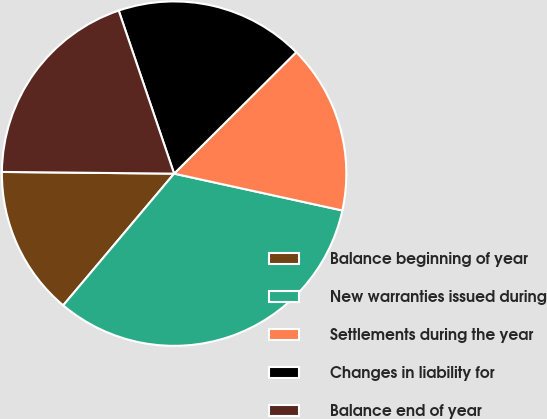Convert chart to OTSL. <chart><loc_0><loc_0><loc_500><loc_500><pie_chart><fcel>Balance beginning of year<fcel>New warranties issued during<fcel>Settlements during the year<fcel>Changes in liability for<fcel>Balance end of year<nl><fcel>14.02%<fcel>32.71%<fcel>15.89%<fcel>17.76%<fcel>19.63%<nl></chart> 